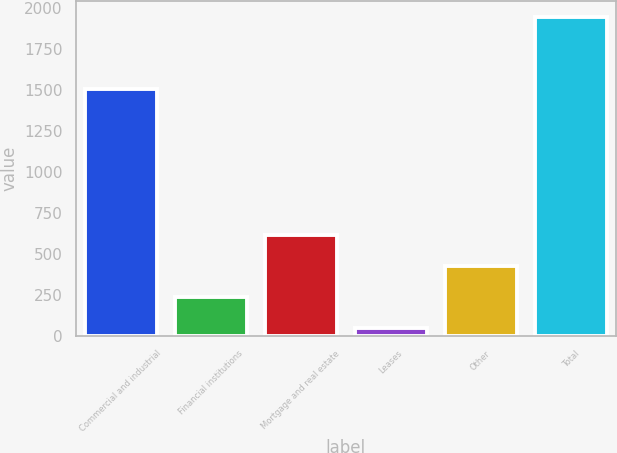<chart> <loc_0><loc_0><loc_500><loc_500><bar_chart><fcel>Commercial and industrial<fcel>Financial institutions<fcel>Mortgage and real estate<fcel>Leases<fcel>Other<fcel>Total<nl><fcel>1506<fcel>235.6<fcel>614.8<fcel>46<fcel>425.2<fcel>1942<nl></chart> 